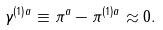<formula> <loc_0><loc_0><loc_500><loc_500>\gamma ^ { ( 1 ) a } \equiv \pi ^ { a } - \pi ^ { ( 1 ) a } \approx 0 .</formula> 